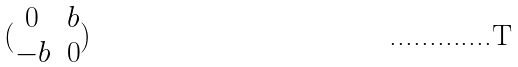Convert formula to latex. <formula><loc_0><loc_0><loc_500><loc_500>( \begin{matrix} 0 & b \\ - b & 0 \end{matrix} )</formula> 